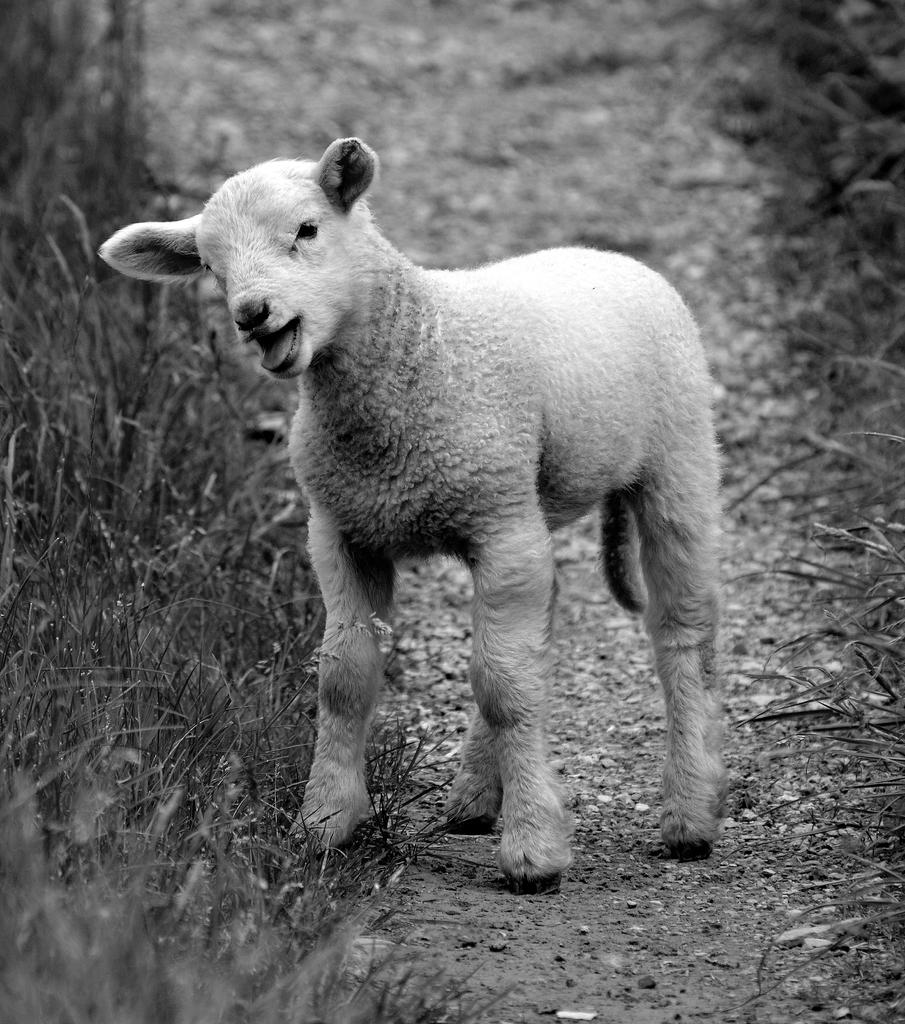What animal can be seen in the image? There is a sheep in the image. What is the sheep's position in the image? The sheep is standing on the ground. What type of vegetation is visible in the image? There is grass visible in the image. What is the color scheme of the image? The image is black and white in color. What type of glue is the sheep using to stick to the seashore in the image? There is no seashore or glue present in the image; it features a sheep standing on grass in a black and white image. 